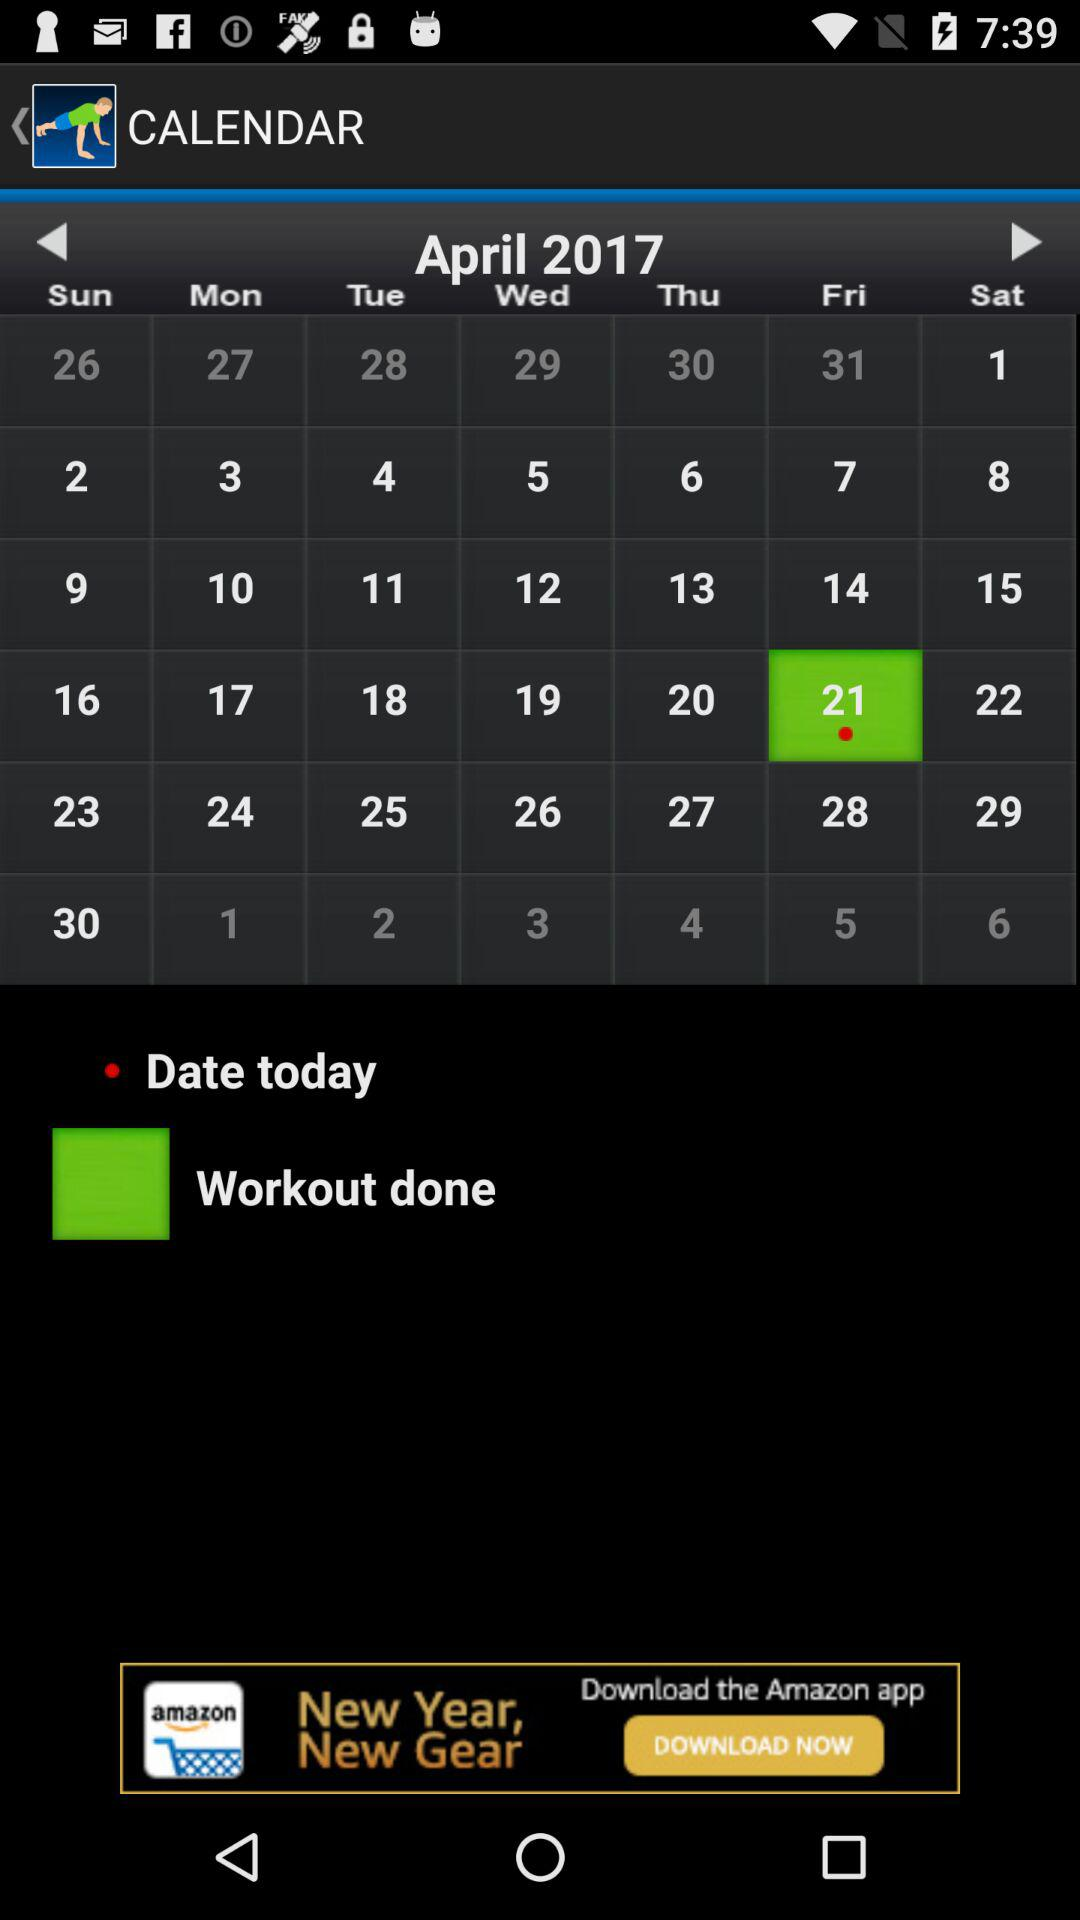Which date is selected? The selected date is Friday, April 21, 2017. 